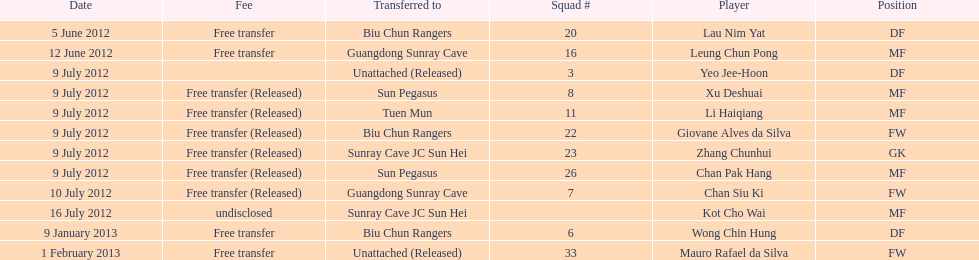I'm looking to parse the entire table for insights. Could you assist me with that? {'header': ['Date', 'Fee', 'Transferred to', 'Squad #', 'Player', 'Position'], 'rows': [['5 June 2012', 'Free transfer', 'Biu Chun Rangers', '20', 'Lau Nim Yat', 'DF'], ['12 June 2012', 'Free transfer', 'Guangdong Sunray Cave', '16', 'Leung Chun Pong', 'MF'], ['9 July 2012', '', 'Unattached (Released)', '3', 'Yeo Jee-Hoon', 'DF'], ['9 July 2012', 'Free transfer (Released)', 'Sun Pegasus', '8', 'Xu Deshuai', 'MF'], ['9 July 2012', 'Free transfer (Released)', 'Tuen Mun', '11', 'Li Haiqiang', 'MF'], ['9 July 2012', 'Free transfer (Released)', 'Biu Chun Rangers', '22', 'Giovane Alves da Silva', 'FW'], ['9 July 2012', 'Free transfer (Released)', 'Sunray Cave JC Sun Hei', '23', 'Zhang Chunhui', 'GK'], ['9 July 2012', 'Free transfer (Released)', 'Sun Pegasus', '26', 'Chan Pak Hang', 'MF'], ['10 July 2012', 'Free transfer (Released)', 'Guangdong Sunray Cave', '7', 'Chan Siu Ki', 'FW'], ['16 July 2012', 'undisclosed', 'Sunray Cave JC Sun Hei', '', 'Kot Cho Wai', 'MF'], ['9 January 2013', 'Free transfer', 'Biu Chun Rangers', '6', 'Wong Chin Hung', 'DF'], ['1 February 2013', 'Free transfer', 'Unattached (Released)', '33', 'Mauro Rafael da Silva', 'FW']]} Wong chin hung was transferred to his new team on what date? 9 January 2013. 